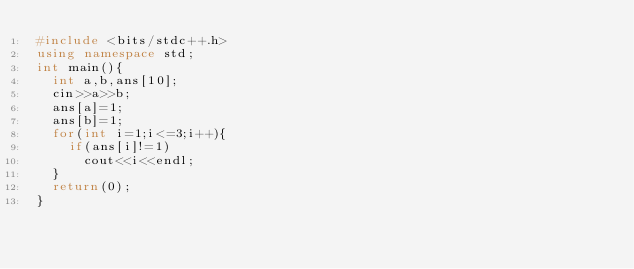<code> <loc_0><loc_0><loc_500><loc_500><_C++_>#include <bits/stdc++.h>
using namespace std;
int main(){
  int a,b,ans[10];
  cin>>a>>b;
  ans[a]=1;
  ans[b]=1;
  for(int i=1;i<=3;i++){
    if(ans[i]!=1)
      cout<<i<<endl;
  }
  return(0);
}</code> 